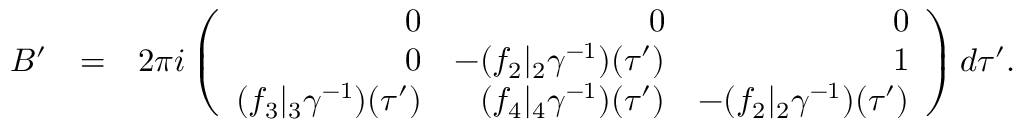Convert formula to latex. <formula><loc_0><loc_0><loc_500><loc_500>\begin{array} { r l r } { B ^ { \prime } } & { = } & { 2 \pi i \left ( \begin{array} { r r r } { 0 } & { 0 } & { 0 } \\ { 0 } & { - ( f _ { 2 } | _ { 2 } \gamma ^ { - 1 } ) ( \tau ^ { \prime } ) } & { 1 } \\ { ( f _ { 3 } | _ { 3 } \gamma ^ { - 1 } ) ( \tau ^ { \prime } ) } & { ( f _ { 4 } | _ { 4 } \gamma ^ { - 1 } ) ( \tau ^ { \prime } ) } & { - ( f _ { 2 } | _ { 2 } \gamma ^ { - 1 } ) ( \tau ^ { \prime } ) } \end{array} \right ) d \tau ^ { \prime } . } \end{array}</formula> 